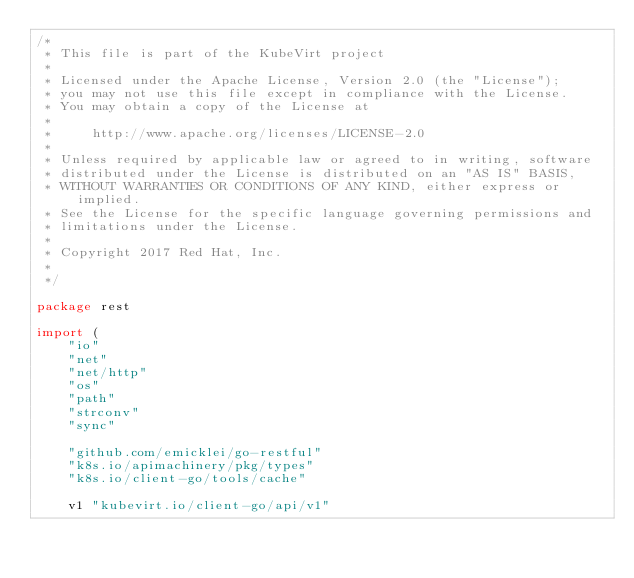<code> <loc_0><loc_0><loc_500><loc_500><_Go_>/*
 * This file is part of the KubeVirt project
 *
 * Licensed under the Apache License, Version 2.0 (the "License");
 * you may not use this file except in compliance with the License.
 * You may obtain a copy of the License at
 *
 *     http://www.apache.org/licenses/LICENSE-2.0
 *
 * Unless required by applicable law or agreed to in writing, software
 * distributed under the License is distributed on an "AS IS" BASIS,
 * WITHOUT WARRANTIES OR CONDITIONS OF ANY KIND, either express or implied.
 * See the License for the specific language governing permissions and
 * limitations under the License.
 *
 * Copyright 2017 Red Hat, Inc.
 *
 */

package rest

import (
	"io"
	"net"
	"net/http"
	"os"
	"path"
	"strconv"
	"sync"

	"github.com/emicklei/go-restful"
	"k8s.io/apimachinery/pkg/types"
	"k8s.io/client-go/tools/cache"

	v1 "kubevirt.io/client-go/api/v1"</code> 